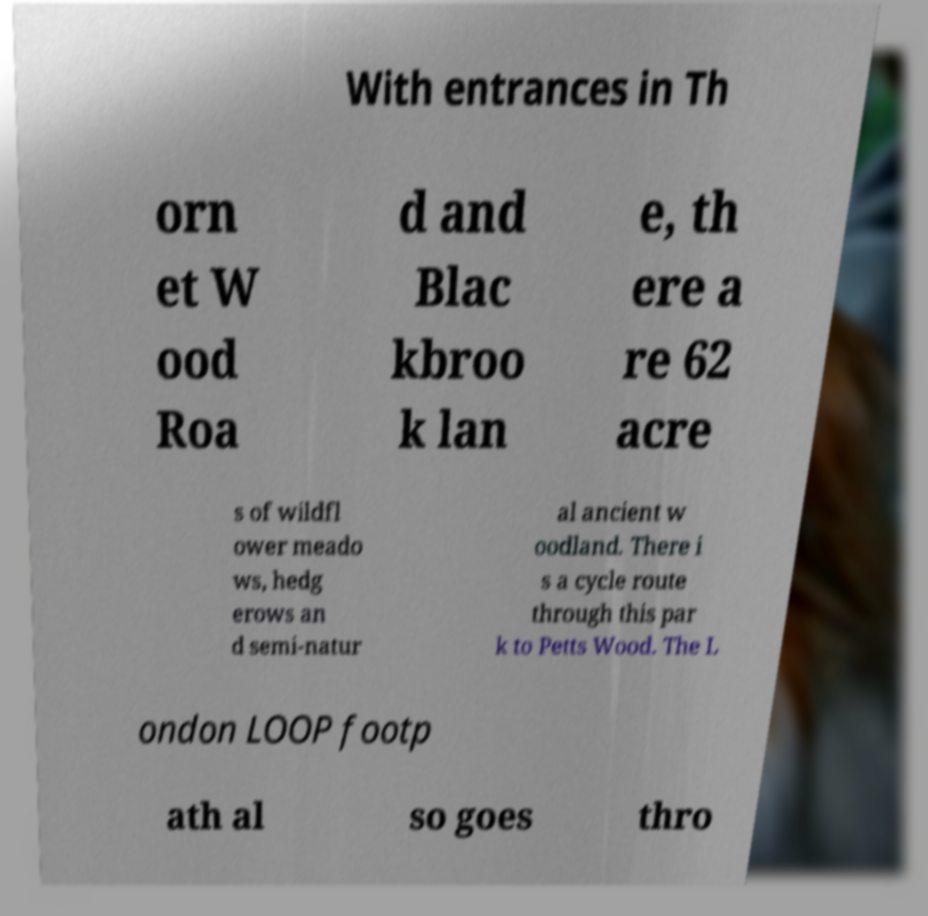Can you read and provide the text displayed in the image?This photo seems to have some interesting text. Can you extract and type it out for me? With entrances in Th orn et W ood Roa d and Blac kbroo k lan e, th ere a re 62 acre s of wildfl ower meado ws, hedg erows an d semi-natur al ancient w oodland. There i s a cycle route through this par k to Petts Wood. The L ondon LOOP footp ath al so goes thro 